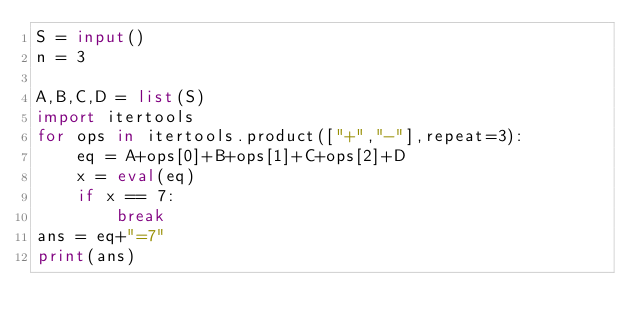Convert code to text. <code><loc_0><loc_0><loc_500><loc_500><_Python_>S = input()
n = 3

A,B,C,D = list(S)
import itertools
for ops in itertools.product(["+","-"],repeat=3):
    eq = A+ops[0]+B+ops[1]+C+ops[2]+D
    x = eval(eq)
    if x == 7:
        break
ans = eq+"=7"
print(ans)</code> 